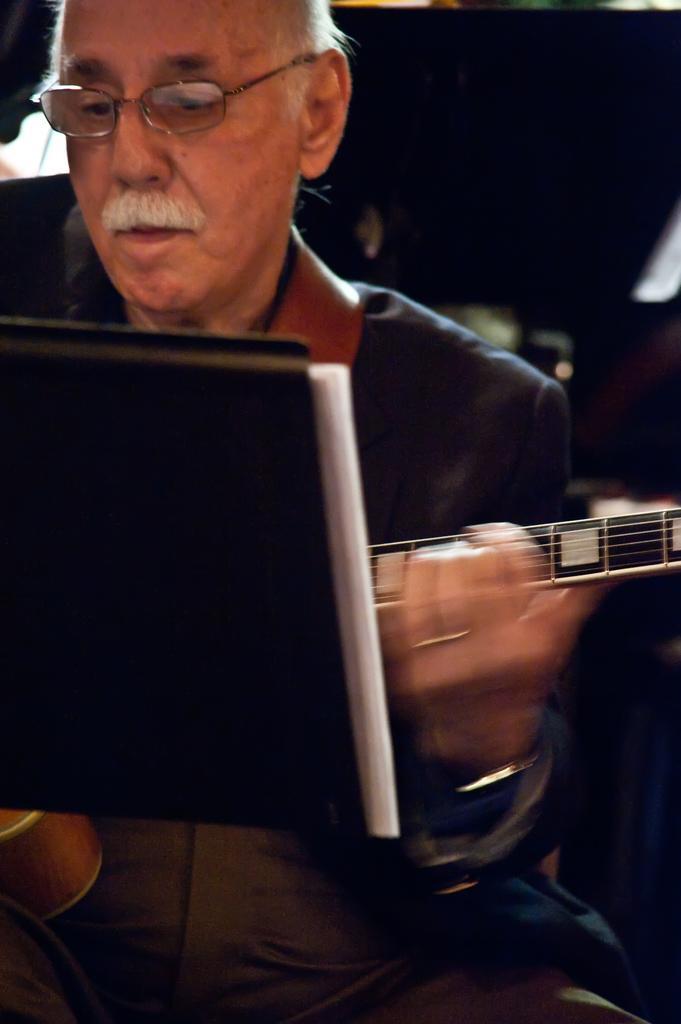Please provide a concise description of this image. In this image i can see a man holding guitar and there is a book in front of him. 